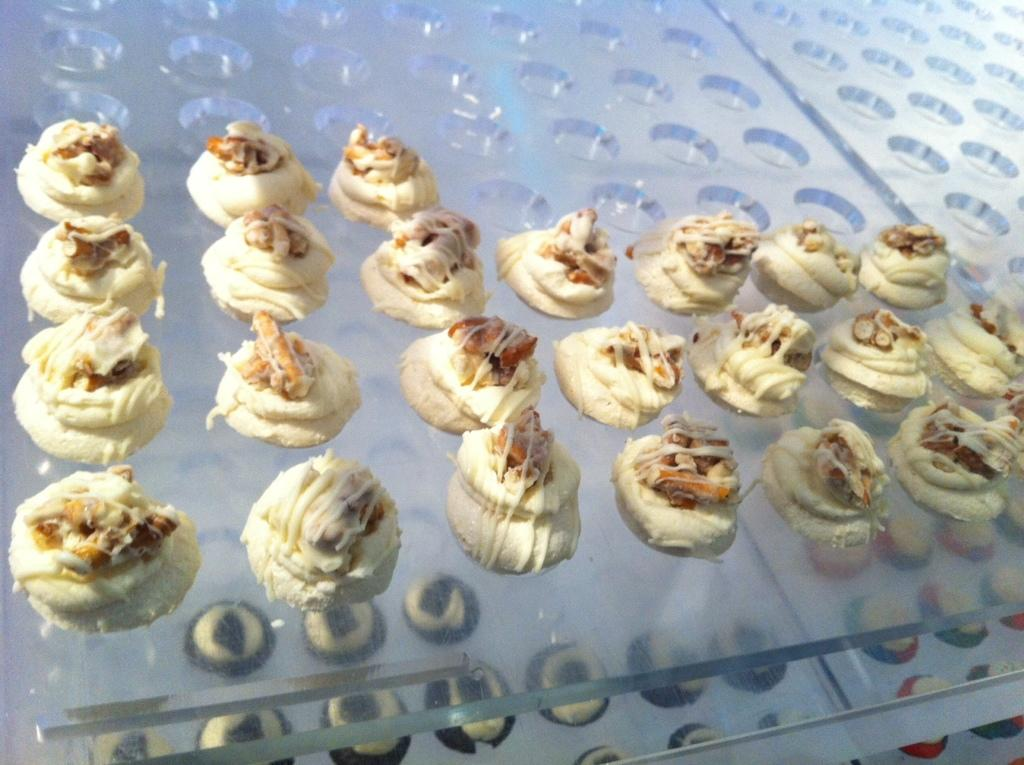What types of items can be seen in the image? There are food items in the image. What material are the surfaces on which the food items are placed? The food items are on glass surfaces. What song is being sung by the food items in the image? There is no song being sung by the food items in the image, as they are inanimate objects. 